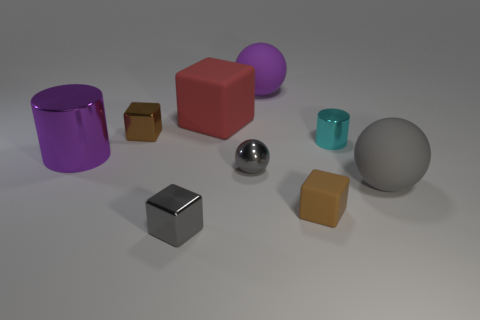What number of objects are either metallic things behind the gray shiny block or gray metallic things behind the large gray rubber sphere?
Give a very brief answer. 4. What color is the thing that is both on the right side of the large block and behind the brown shiny thing?
Your response must be concise. Purple. Are there more big green matte cylinders than tiny spheres?
Your response must be concise. No. Do the small metallic thing that is on the left side of the tiny gray cube and the big gray object have the same shape?
Your answer should be compact. No. How many matte things are either tiny gray things or yellow cylinders?
Keep it short and to the point. 0. Is there a small red cylinder that has the same material as the red thing?
Ensure brevity in your answer.  No. What is the material of the large purple cylinder?
Give a very brief answer. Metal. The gray object in front of the matte ball that is in front of the small brown thing behind the large gray rubber sphere is what shape?
Provide a succinct answer. Cube. Are there more gray rubber objects that are on the left side of the big purple cylinder than tiny brown metallic objects?
Your answer should be very brief. No. There is a red matte object; is it the same shape as the purple object that is right of the purple metal object?
Offer a terse response. No. 